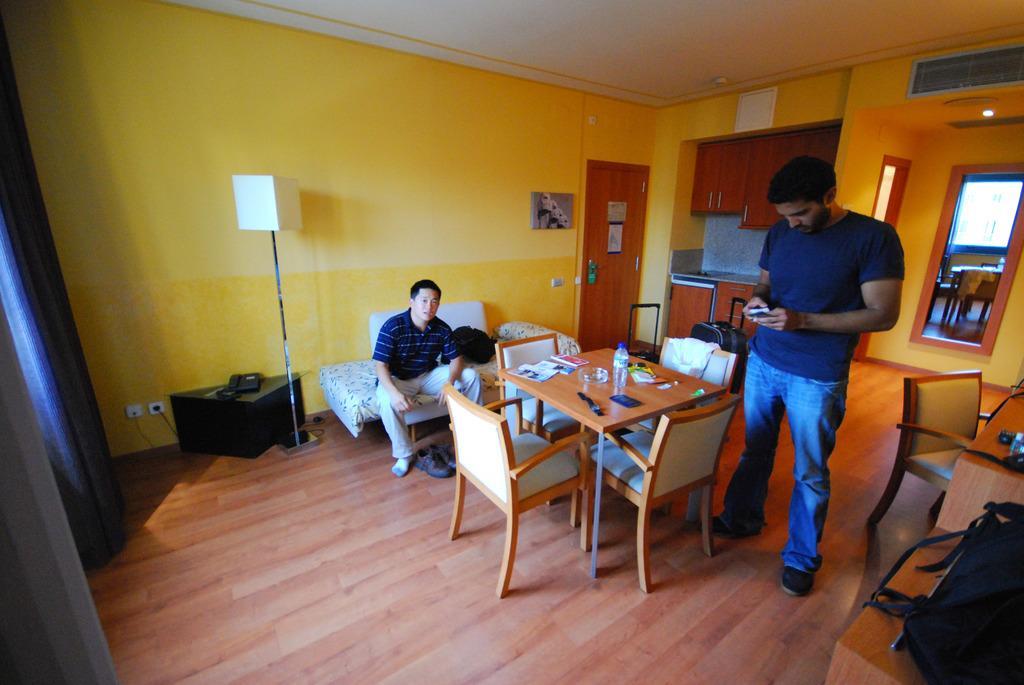Please provide a concise description of this image. In this image there are two persons. At the right side of the image there is a person standing and holding a object and at the left side of the image there is a person sitting on the bed. 